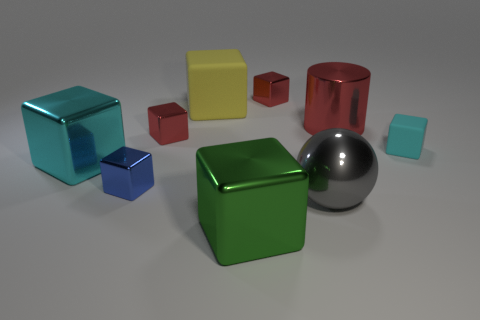What is the size of the metal cube that is the same color as the small rubber block?
Provide a succinct answer. Large. Do the cylinder and the small thing behind the large yellow thing have the same color?
Your answer should be compact. Yes. There is a cyan thing on the left side of the large green shiny object; what is its size?
Give a very brief answer. Large. There is a cyan cube that is the same size as the blue shiny object; what material is it?
Your answer should be compact. Rubber. Is the large green object the same shape as the yellow thing?
Keep it short and to the point. Yes. How many objects are either big red metal cylinders or matte blocks that are left of the large green shiny thing?
Offer a terse response. 2. There is a cyan thing that is left of the gray metal thing; is it the same size as the big gray shiny ball?
Offer a terse response. Yes. There is a red cube in front of the tiny red metal thing on the right side of the large green shiny block; how many cyan things are to the left of it?
Offer a terse response. 1. What number of brown objects are large metallic cylinders or small matte objects?
Provide a short and direct response. 0. There is a big cylinder that is the same material as the green block; what color is it?
Make the answer very short. Red. 